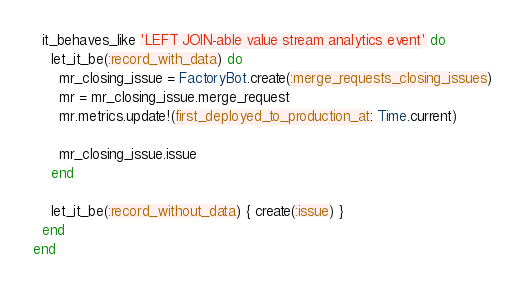Convert code to text. <code><loc_0><loc_0><loc_500><loc_500><_Ruby_>
  it_behaves_like 'LEFT JOIN-able value stream analytics event' do
    let_it_be(:record_with_data) do
      mr_closing_issue = FactoryBot.create(:merge_requests_closing_issues)
      mr = mr_closing_issue.merge_request
      mr.metrics.update!(first_deployed_to_production_at: Time.current)

      mr_closing_issue.issue
    end

    let_it_be(:record_without_data) { create(:issue) }
  end
end
</code> 